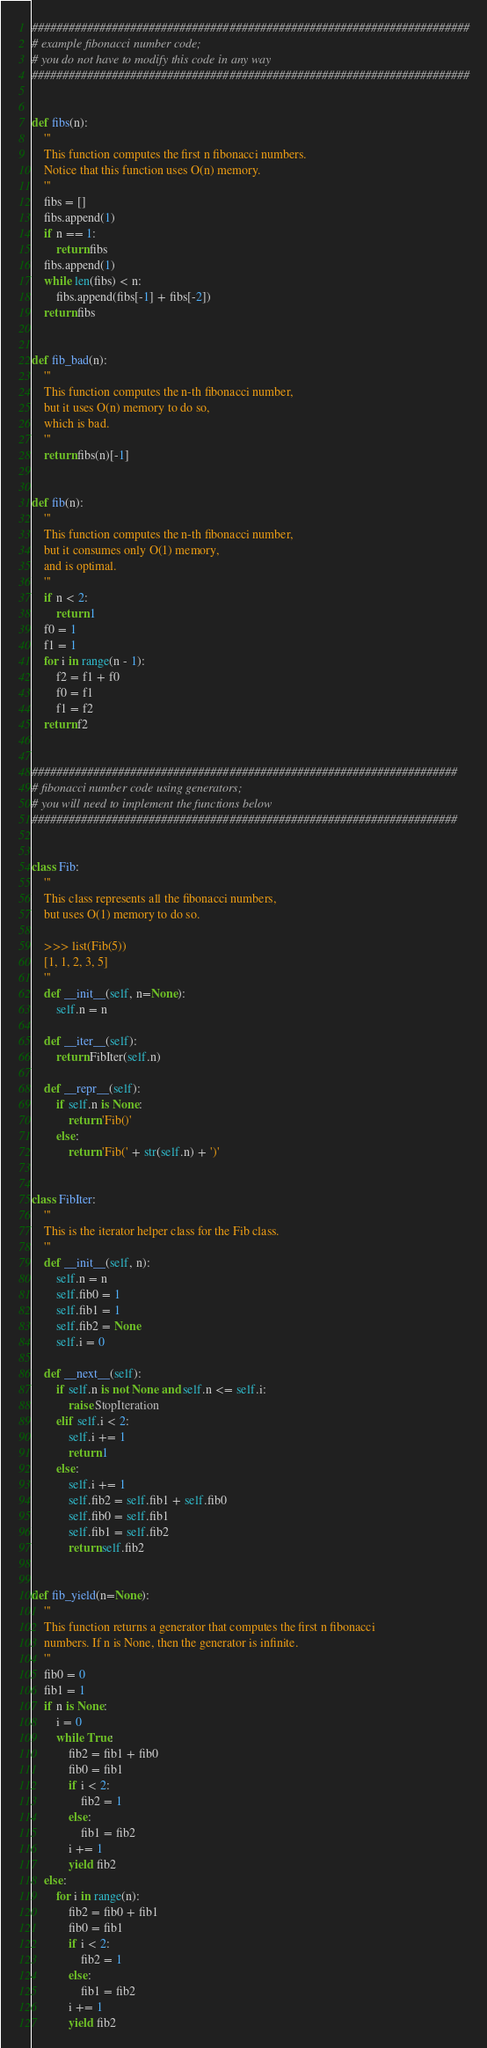<code> <loc_0><loc_0><loc_500><loc_500><_Python_>
#######################################################################
# example fibonacci number code;
# you do not have to modify this code in any way
#######################################################################


def fibs(n):
    '''
    This function computes the first n fibonacci numbers.
    Notice that this function uses O(n) memory.
    '''
    fibs = []
    fibs.append(1)
    if n == 1:
        return fibs
    fibs.append(1)
    while len(fibs) < n:
        fibs.append(fibs[-1] + fibs[-2])
    return fibs


def fib_bad(n):
    '''
    This function computes the n-th fibonacci number,
    but it uses O(n) memory to do so,
    which is bad.
    '''
    return fibs(n)[-1]


def fib(n):
    '''
    This function computes the n-th fibonacci number,
    but it consumes only O(1) memory,
    and is optimal.
    '''
    if n < 2:
        return 1
    f0 = 1
    f1 = 1
    for i in range(n - 1):
        f2 = f1 + f0
        f0 = f1
        f1 = f2
    return f2


#####################################################################
# fibonacci number code using generators;
# you will need to implement the functions below
#####################################################################


class Fib:
    '''
    This class represents all the fibonacci numbers,
    but uses O(1) memory to do so.

    >>> list(Fib(5))
    [1, 1, 2, 3, 5]
    '''
    def __init__(self, n=None):
        self.n = n

    def __iter__(self):
        return FibIter(self.n)

    def __repr__(self):
        if self.n is None:
            return 'Fib()'
        else:
            return 'Fib(' + str(self.n) + ')'


class FibIter:
    '''
    This is the iterator helper class for the Fib class.
    '''
    def __init__(self, n):
        self.n = n
        self.fib0 = 1
        self.fib1 = 1
        self.fib2 = None
        self.i = 0

    def __next__(self):
        if self.n is not None and self.n <= self.i:
            raise StopIteration
        elif self.i < 2:
            self.i += 1
            return 1
        else:
            self.i += 1
            self.fib2 = self.fib1 + self.fib0
            self.fib0 = self.fib1
            self.fib1 = self.fib2
            return self.fib2


def fib_yield(n=None):
    '''
    This function returns a generator that computes the first n fibonacci
    numbers. If n is None, then the generator is infinite.
    '''
    fib0 = 0
    fib1 = 1
    if n is None:
        i = 0
        while True:
            fib2 = fib1 + fib0
            fib0 = fib1
            if i < 2:
                fib2 = 1
            else:
                fib1 = fib2
            i += 1
            yield fib2
    else:
        for i in range(n):
            fib2 = fib0 + fib1
            fib0 = fib1
            if i < 2:
                fib2 = 1
            else:
                fib1 = fib2
            i += 1
            yield fib2
</code> 